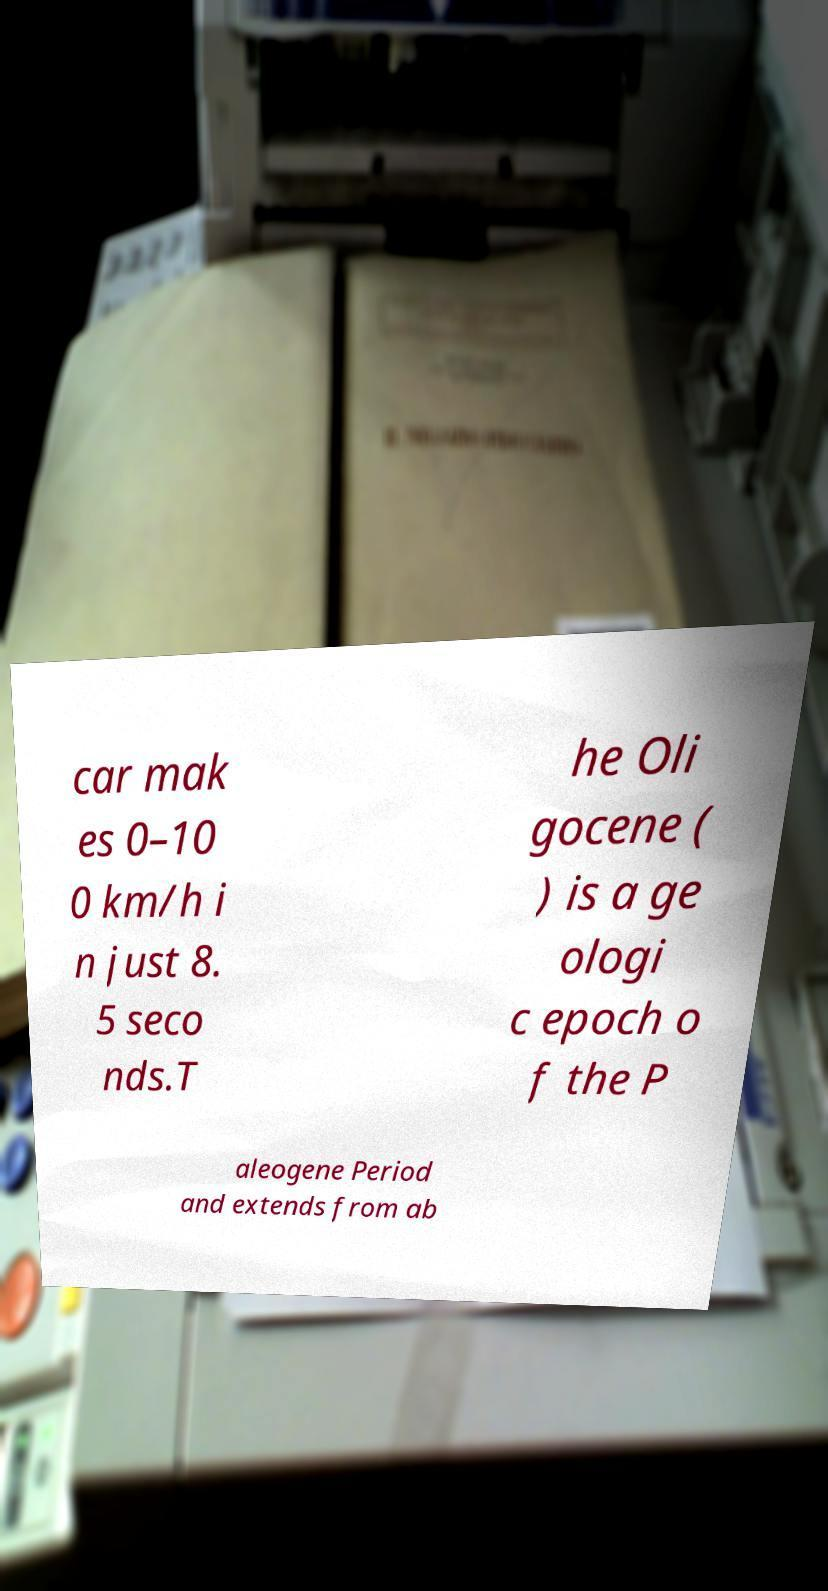There's text embedded in this image that I need extracted. Can you transcribe it verbatim? car mak es 0–10 0 km/h i n just 8. 5 seco nds.T he Oli gocene ( ) is a ge ologi c epoch o f the P aleogene Period and extends from ab 